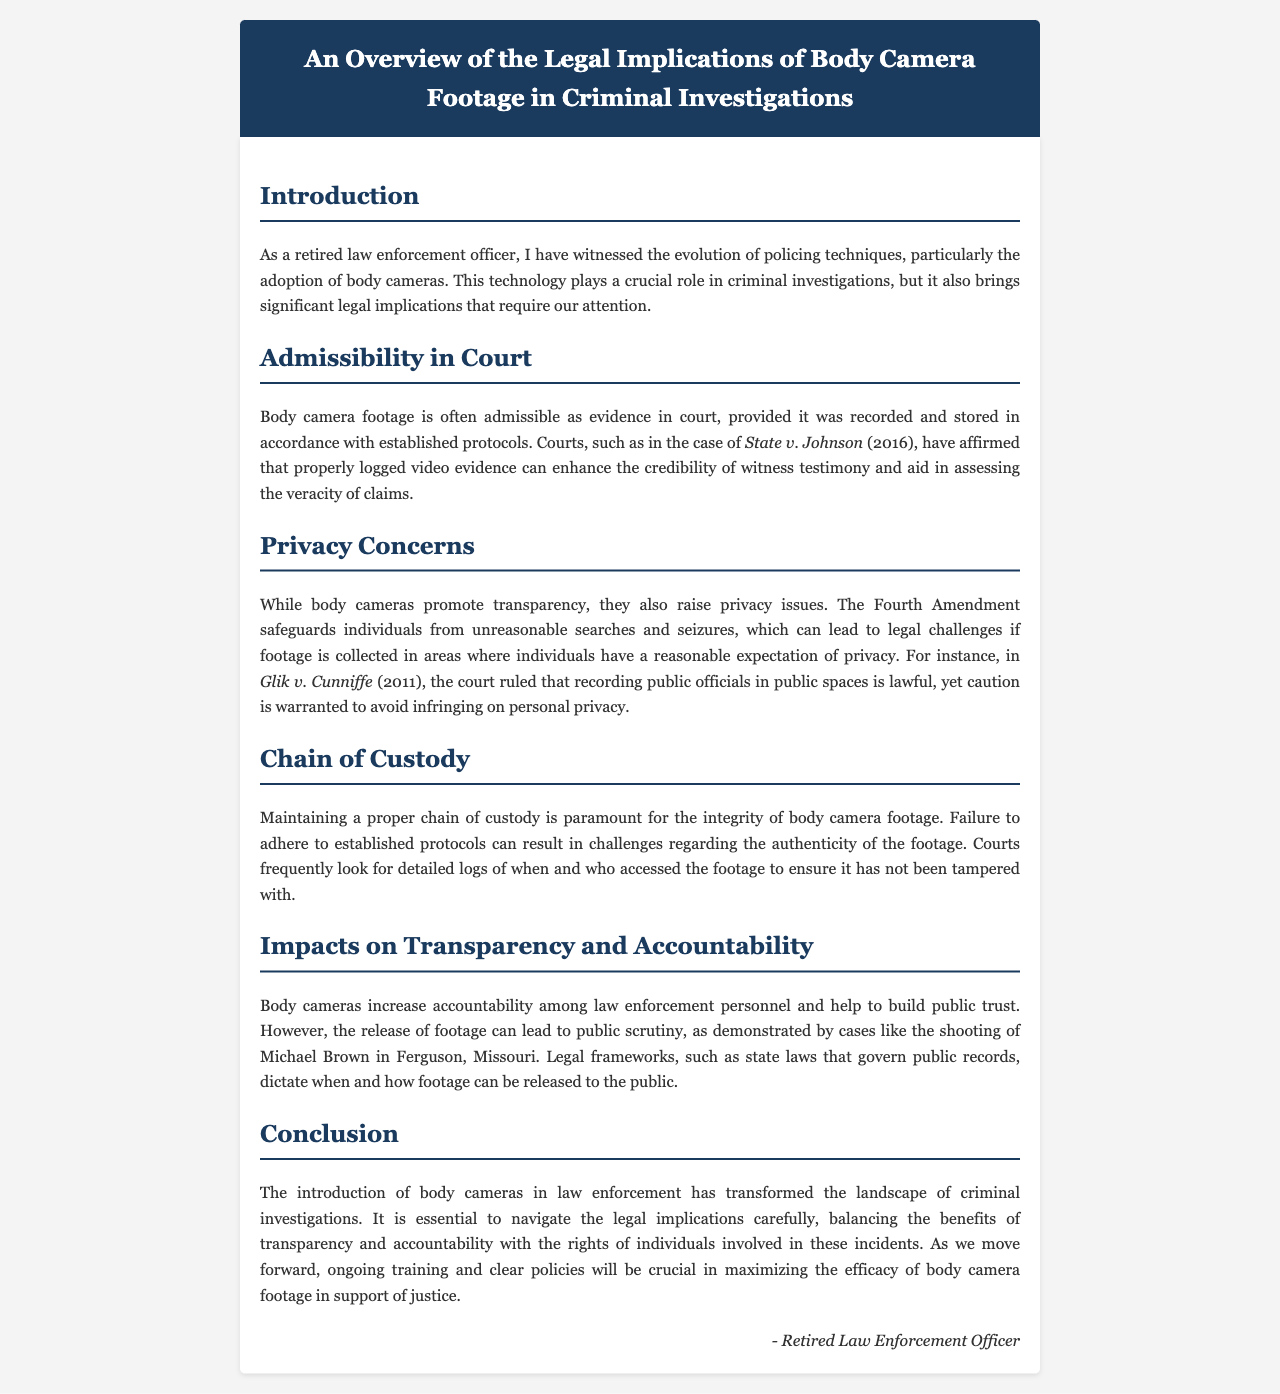What is the title of the document? The title is explicitly stated in the header of the document, "An Overview of the Legal Implications of Body Camera Footage in Criminal Investigations."
Answer: An Overview of the Legal Implications of Body Camera Footage in Criminal Investigations What year was the case State v. Johnson decided? The case mentioned is referenced along with its decision year, 2016.
Answer: 2016 What amendment safeguards individuals from unreasonable searches? The Fourth Amendment is referred to in the context of privacy issues.
Answer: Fourth Amendment Who wrote the document? The document is signed by a "Retired Law Enforcement Officer" at the end.
Answer: Retired Law Enforcement Officer What court case is cited in discussing the legality of recording public officials? The document cites "Glik v. Cunniffe" as relevant to this issue.
Answer: Glik v. Cunniffe What impacts do body cameras have on law enforcement personnel? The document states that body cameras increase accountability among law enforcement personnel.
Answer: Accountability What is necessary for the integrity of body camera footage? The text emphasizes the importance of maintaining a proper chain of custody.
Answer: Chain of custody What event is mentioned concerning public scrutiny of body camera footage release? The document refers to the shooting of Michael Brown in Ferguson, Missouri.
Answer: Michael Brown shooting What is essential to maximize the efficacy of body camera footage? Ongoing training and clear policies are stated as crucial for this purpose.
Answer: Ongoing training and clear policies 